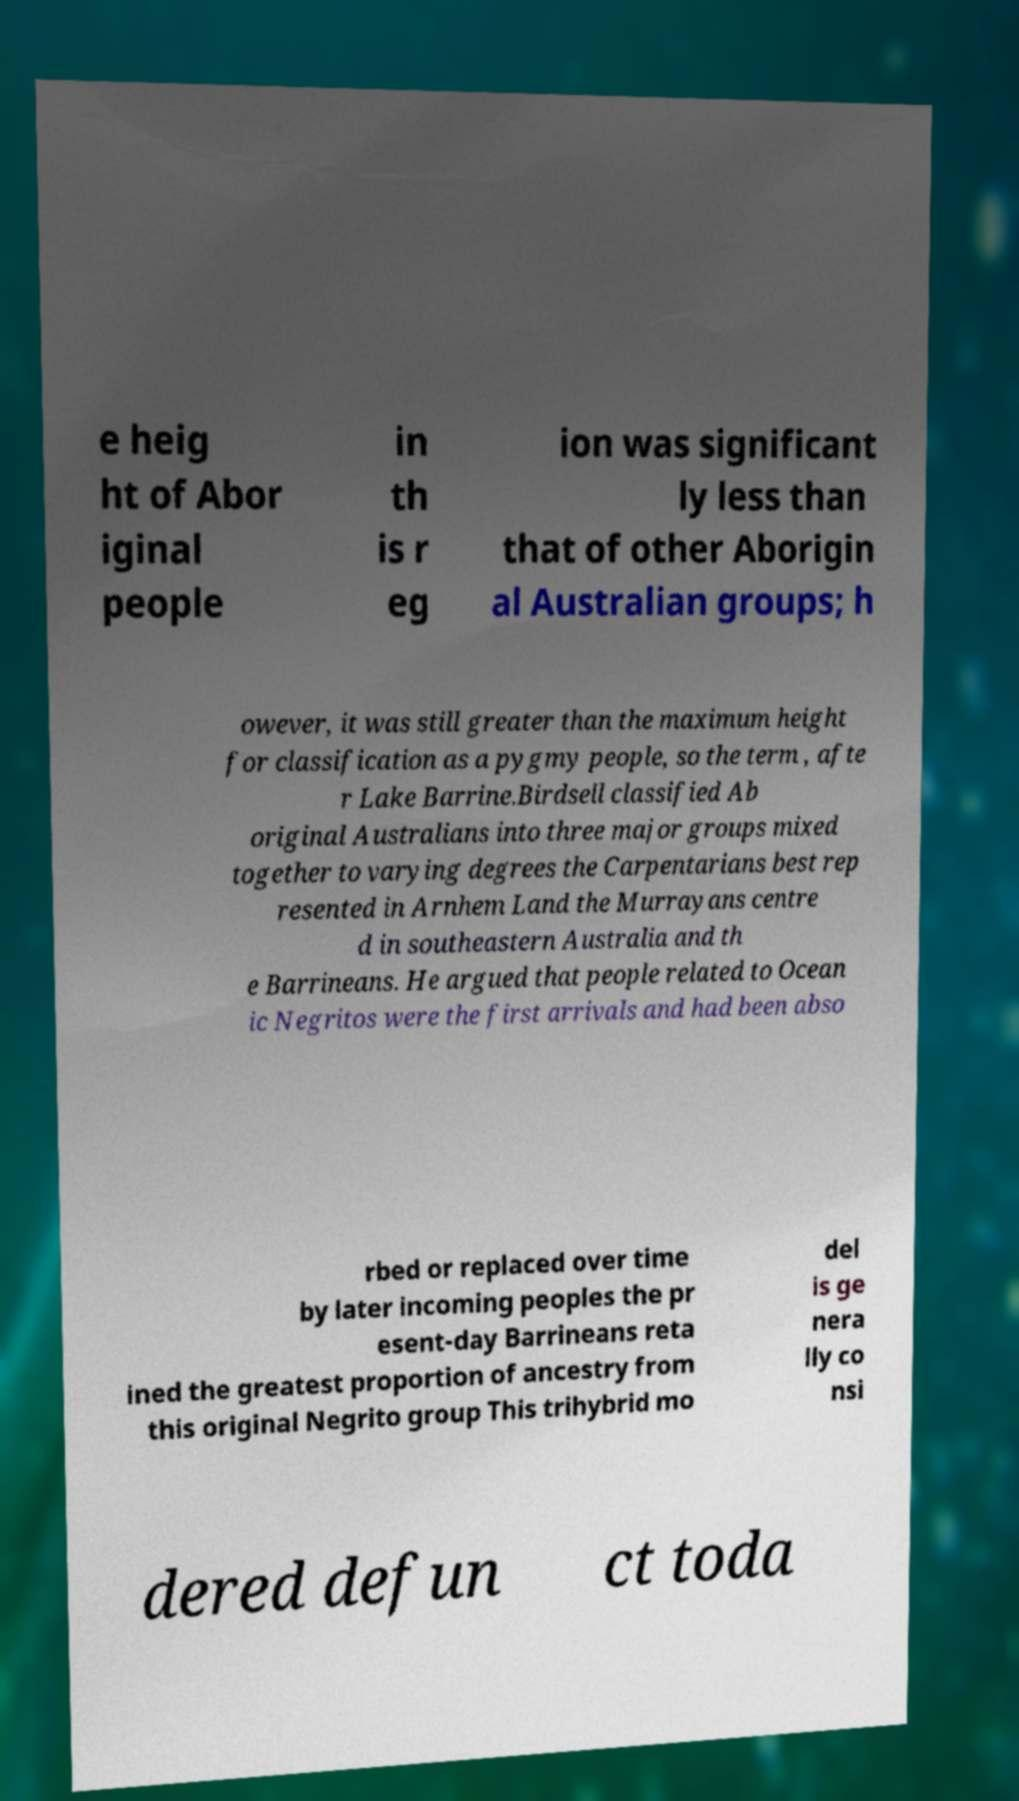Please read and relay the text visible in this image. What does it say? e heig ht of Abor iginal people in th is r eg ion was significant ly less than that of other Aborigin al Australian groups; h owever, it was still greater than the maximum height for classification as a pygmy people, so the term , afte r Lake Barrine.Birdsell classified Ab original Australians into three major groups mixed together to varying degrees the Carpentarians best rep resented in Arnhem Land the Murrayans centre d in southeastern Australia and th e Barrineans. He argued that people related to Ocean ic Negritos were the first arrivals and had been abso rbed or replaced over time by later incoming peoples the pr esent-day Barrineans reta ined the greatest proportion of ancestry from this original Negrito group This trihybrid mo del is ge nera lly co nsi dered defun ct toda 